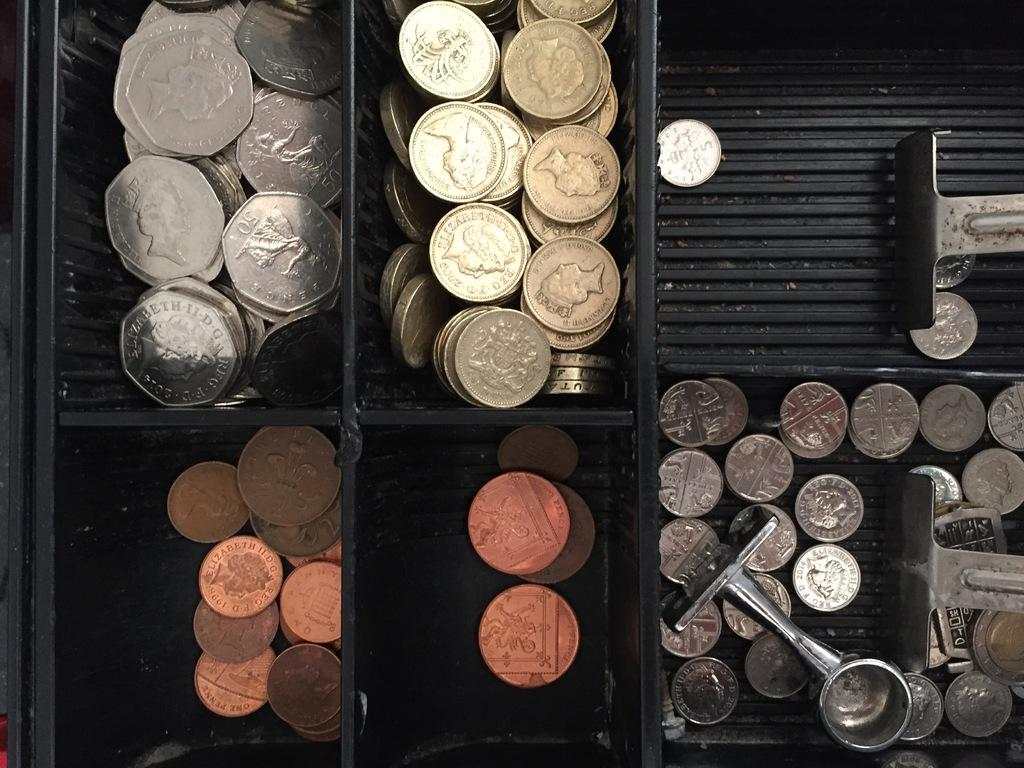<image>
Render a clear and concise summary of the photo. The fifty cent silver piece on the left has Queen Elizabeth II D.G. on it. 